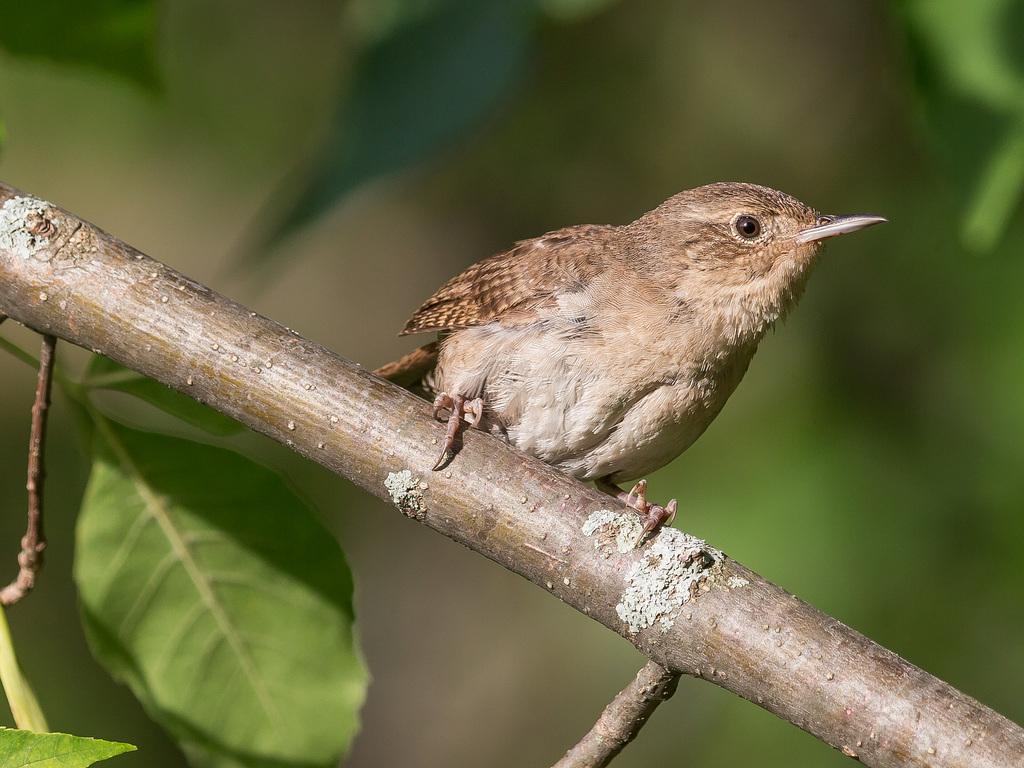Can you describe this image briefly? In the center of the image we can see a bird on the stem. At the bottom there are leaves. 